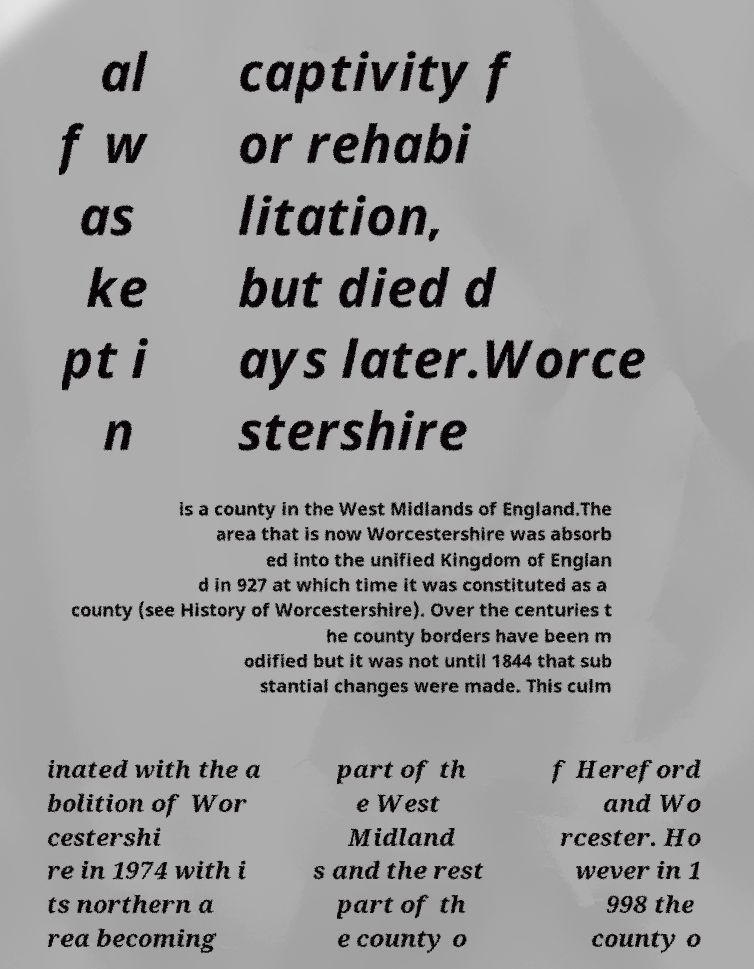Could you assist in decoding the text presented in this image and type it out clearly? al f w as ke pt i n captivity f or rehabi litation, but died d ays later.Worce stershire is a county in the West Midlands of England.The area that is now Worcestershire was absorb ed into the unified Kingdom of Englan d in 927 at which time it was constituted as a county (see History of Worcestershire). Over the centuries t he county borders have been m odified but it was not until 1844 that sub stantial changes were made. This culm inated with the a bolition of Wor cestershi re in 1974 with i ts northern a rea becoming part of th e West Midland s and the rest part of th e county o f Hereford and Wo rcester. Ho wever in 1 998 the county o 